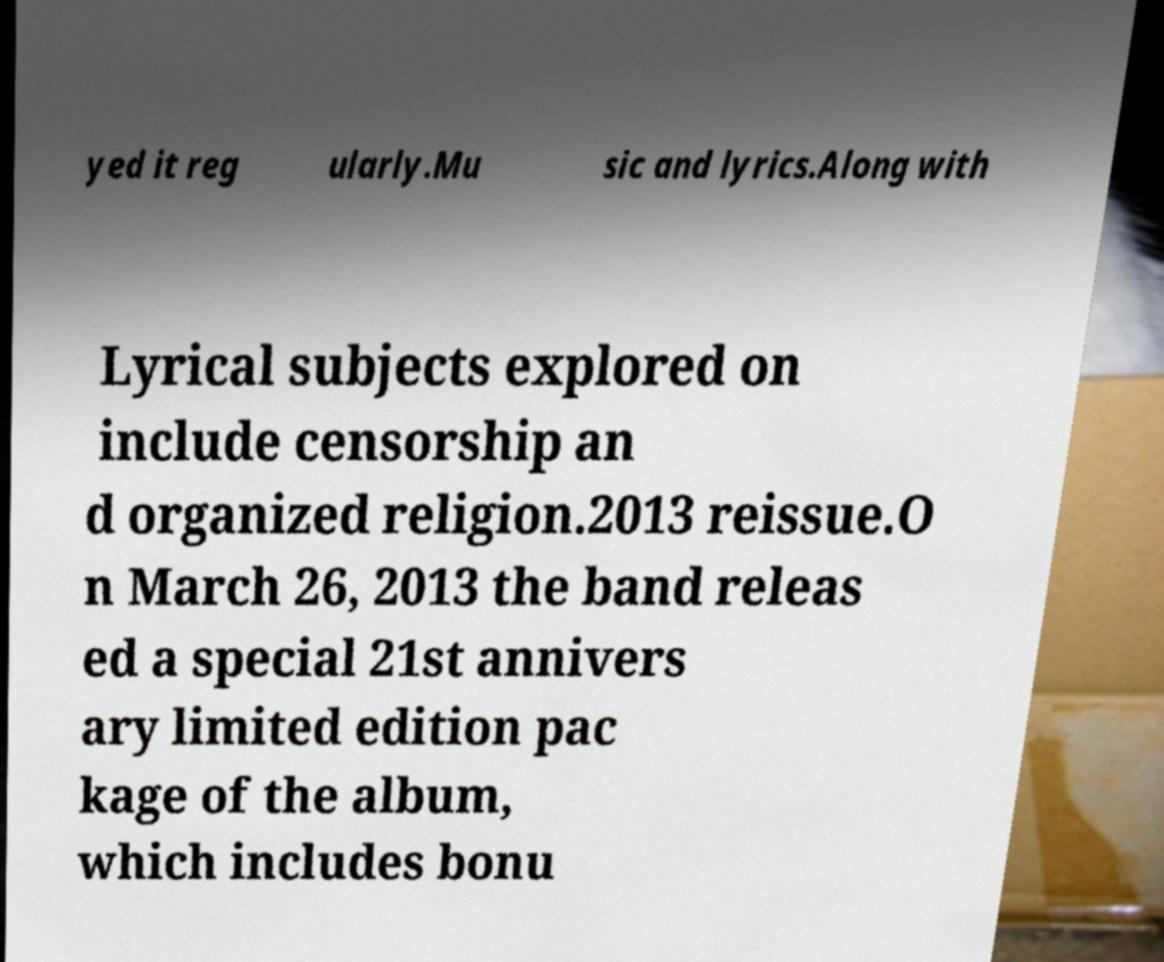What messages or text are displayed in this image? I need them in a readable, typed format. yed it reg ularly.Mu sic and lyrics.Along with Lyrical subjects explored on include censorship an d organized religion.2013 reissue.O n March 26, 2013 the band releas ed a special 21st annivers ary limited edition pac kage of the album, which includes bonu 